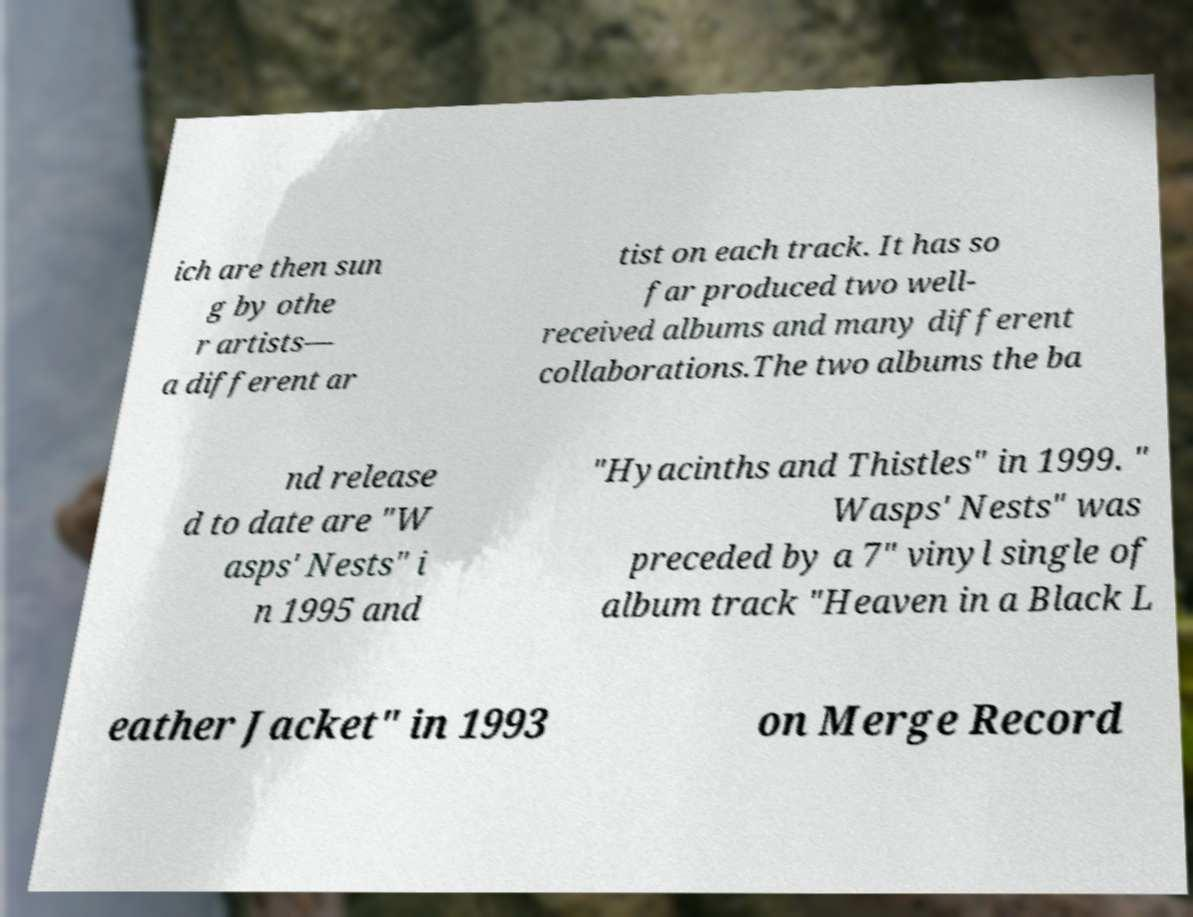Could you assist in decoding the text presented in this image and type it out clearly? ich are then sun g by othe r artists— a different ar tist on each track. It has so far produced two well- received albums and many different collaborations.The two albums the ba nd release d to date are "W asps' Nests" i n 1995 and "Hyacinths and Thistles" in 1999. " Wasps' Nests" was preceded by a 7" vinyl single of album track "Heaven in a Black L eather Jacket" in 1993 on Merge Record 